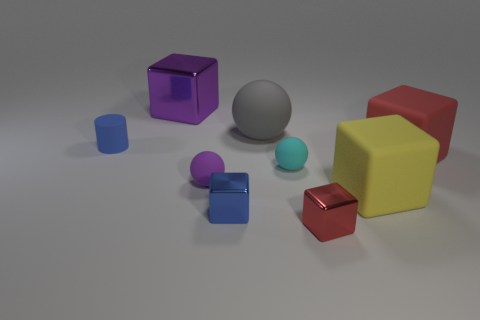Subtract all small blue cubes. How many cubes are left? 4 Add 1 tiny blue matte cylinders. How many objects exist? 10 Subtract all purple balls. How many balls are left? 2 Subtract all blocks. How many objects are left? 4 Subtract all cyan spheres. How many red blocks are left? 2 Add 9 tiny cyan rubber objects. How many tiny cyan rubber objects are left? 10 Add 4 green balls. How many green balls exist? 4 Subtract 0 gray blocks. How many objects are left? 9 Subtract 1 blocks. How many blocks are left? 4 Subtract all gray spheres. Subtract all brown cylinders. How many spheres are left? 2 